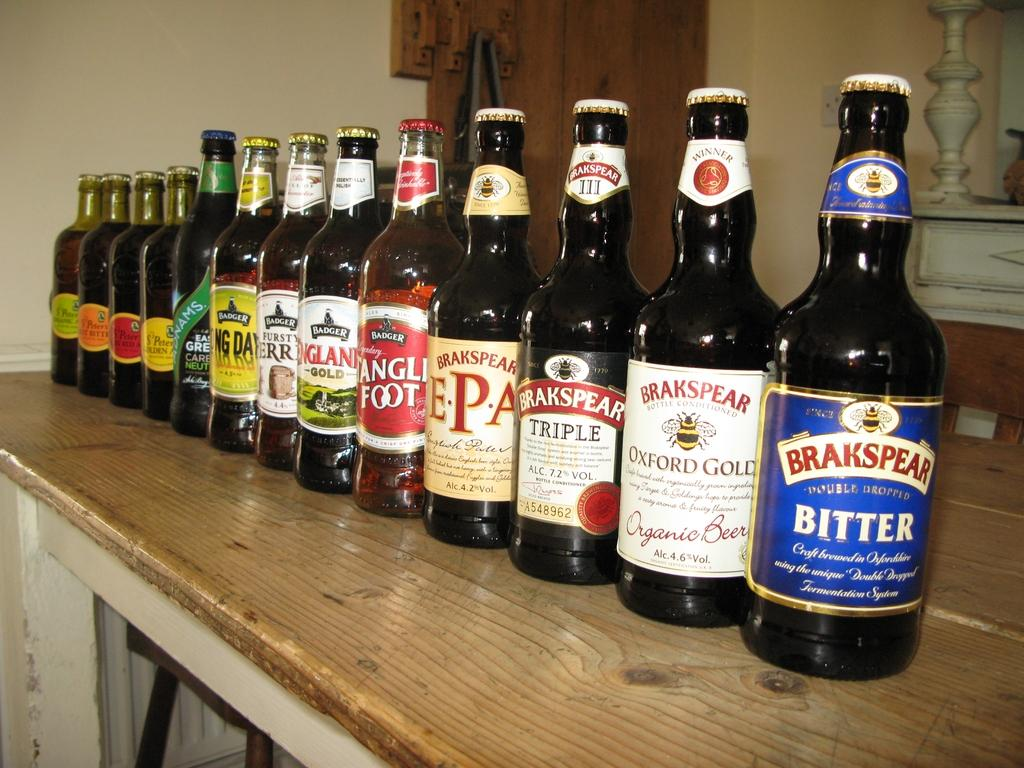<image>
Write a terse but informative summary of the picture. One bottle of Double Dropped Bitter that was craft brewed in Oxfordshire. 